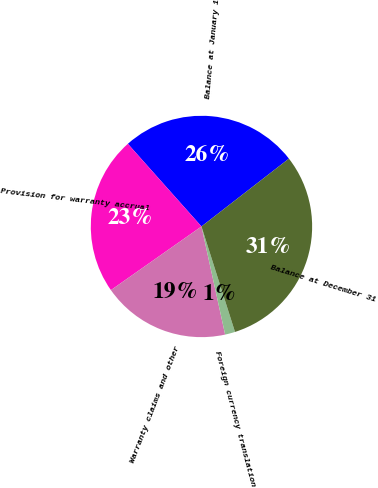Convert chart. <chart><loc_0><loc_0><loc_500><loc_500><pie_chart><fcel>Balance at January 1<fcel>Provision for warranty accrual<fcel>Warranty claims and other<fcel>Foreign currency translation<fcel>Balance at December 31<nl><fcel>26.08%<fcel>23.17%<fcel>18.68%<fcel>1.47%<fcel>30.6%<nl></chart> 